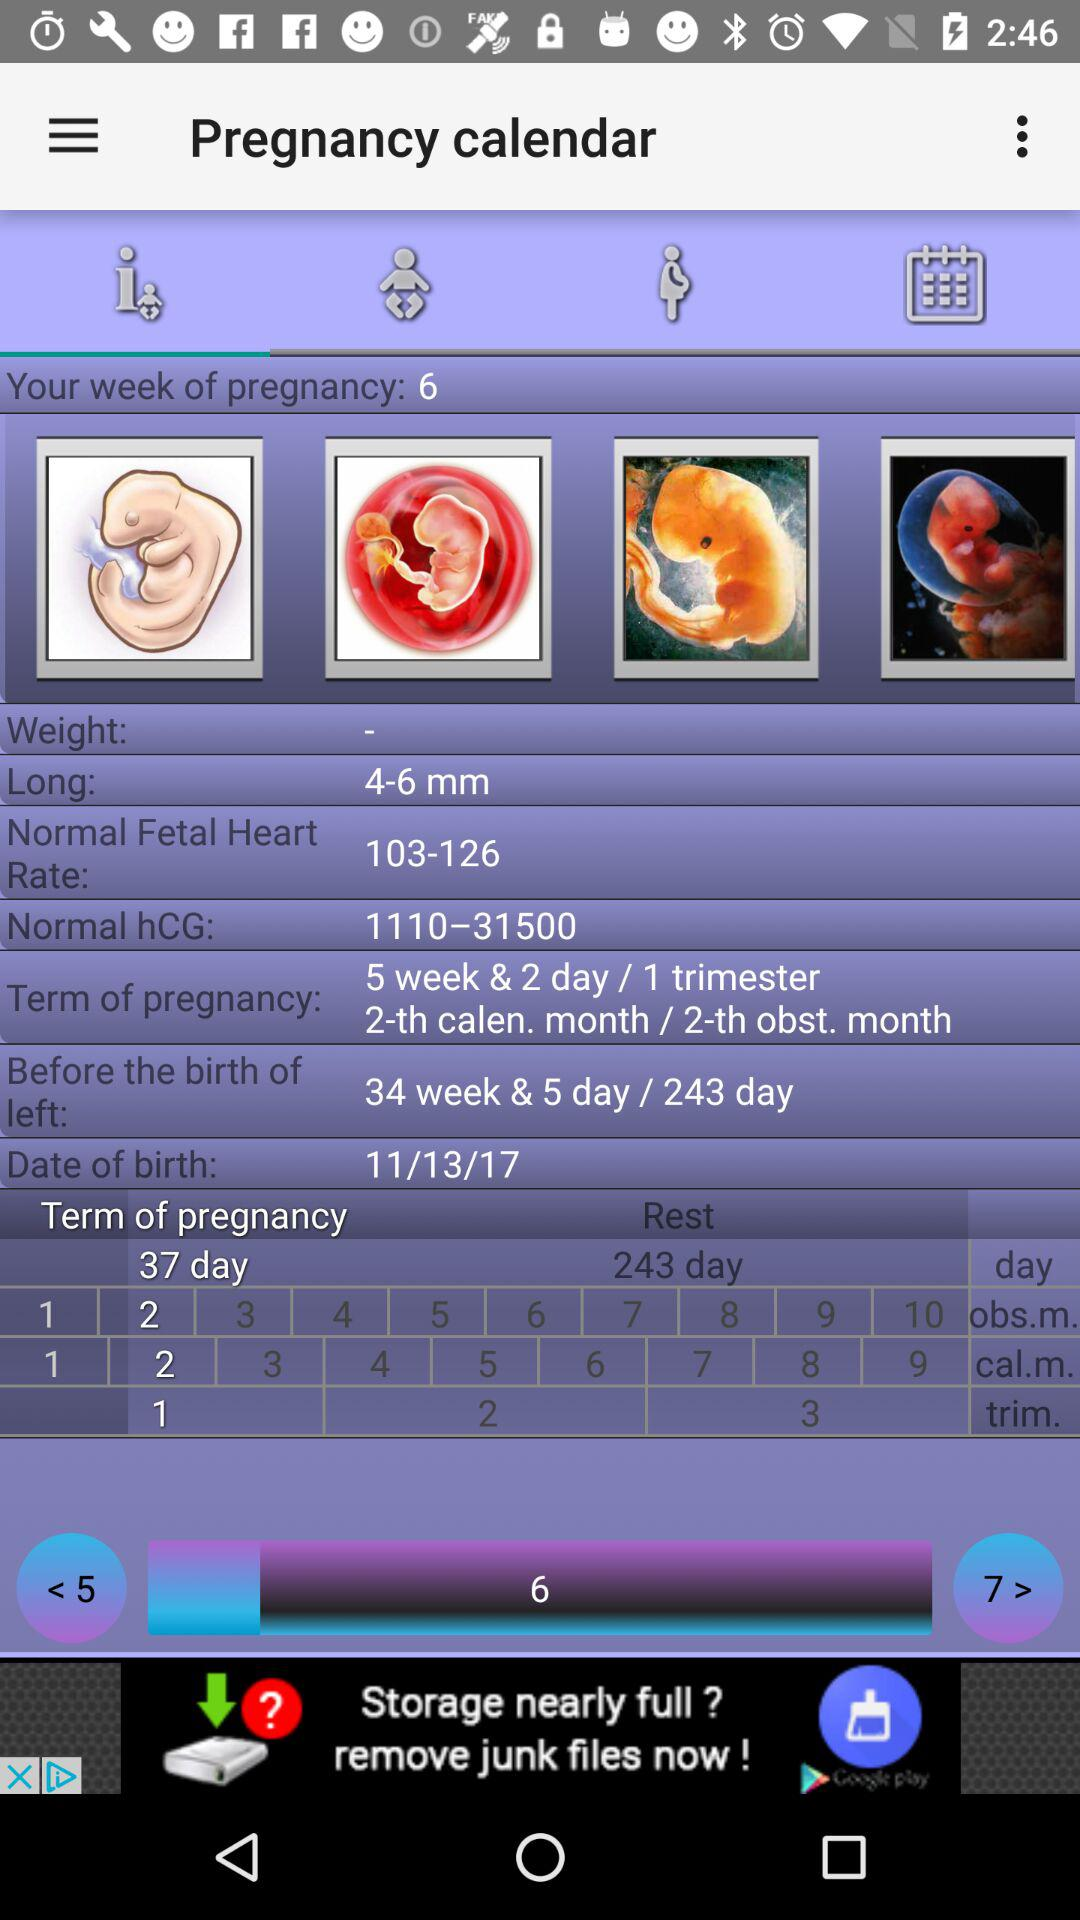What is the normal fetal heart rate? The normal fetal heart rate is 103-126. 